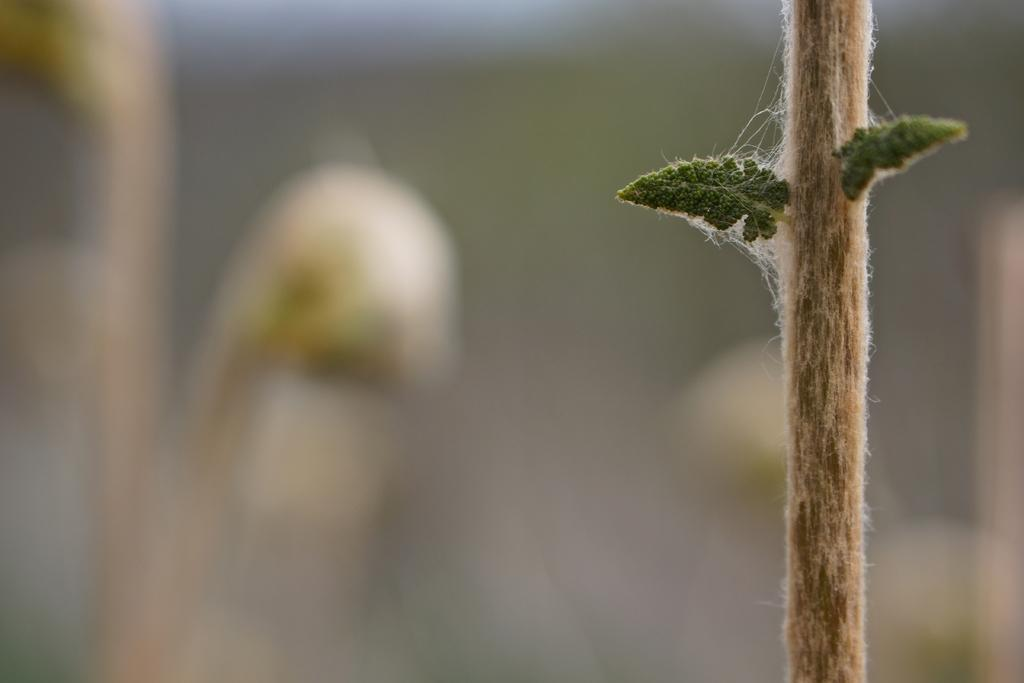What is the main subject of the image? There is a plant in the center of the image. Can you describe the plant in the image? Unfortunately, the provided facts do not include any details about the plant's appearance or characteristics. Is there anything else visible in the image besides the plant? The provided facts do not mention only the presence of a plant in the image, so it is impossible to determine if there are any other objects or subjects present. What type of holiday is being celebrated in the image? There is no indication of a holiday being celebrated in the image, as it only features a plant in the center. Can you describe the smell of the plant in the image? The provided facts do not include any information about the plant's scent, so it is impossible to describe its smell. 